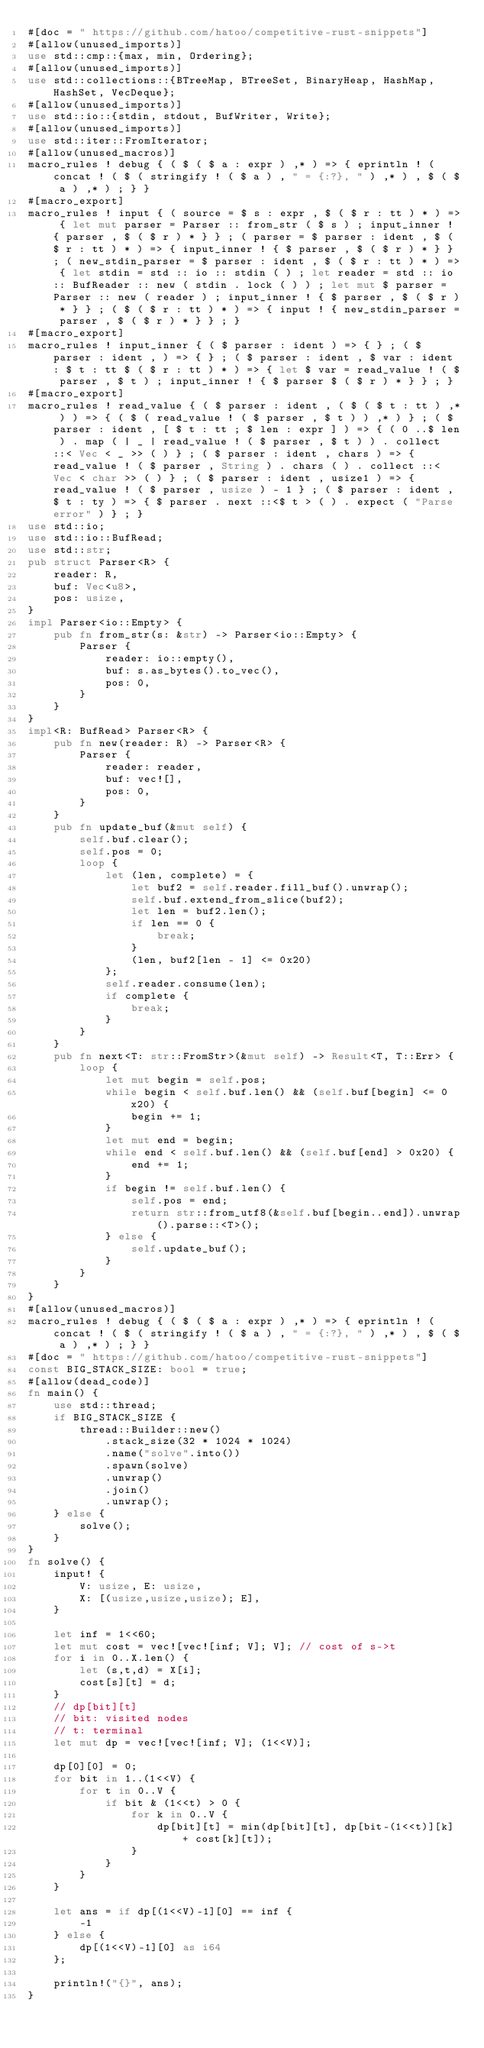<code> <loc_0><loc_0><loc_500><loc_500><_Rust_>#[doc = " https://github.com/hatoo/competitive-rust-snippets"]
#[allow(unused_imports)]
use std::cmp::{max, min, Ordering};
#[allow(unused_imports)]
use std::collections::{BTreeMap, BTreeSet, BinaryHeap, HashMap, HashSet, VecDeque};
#[allow(unused_imports)]
use std::io::{stdin, stdout, BufWriter, Write};
#[allow(unused_imports)]
use std::iter::FromIterator;
#[allow(unused_macros)]
macro_rules ! debug { ( $ ( $ a : expr ) ,* ) => { eprintln ! ( concat ! ( $ ( stringify ! ( $ a ) , " = {:?}, " ) ,* ) , $ ( $ a ) ,* ) ; } }
#[macro_export]
macro_rules ! input { ( source = $ s : expr , $ ( $ r : tt ) * ) => { let mut parser = Parser :: from_str ( $ s ) ; input_inner ! { parser , $ ( $ r ) * } } ; ( parser = $ parser : ident , $ ( $ r : tt ) * ) => { input_inner ! { $ parser , $ ( $ r ) * } } ; ( new_stdin_parser = $ parser : ident , $ ( $ r : tt ) * ) => { let stdin = std :: io :: stdin ( ) ; let reader = std :: io :: BufReader :: new ( stdin . lock ( ) ) ; let mut $ parser = Parser :: new ( reader ) ; input_inner ! { $ parser , $ ( $ r ) * } } ; ( $ ( $ r : tt ) * ) => { input ! { new_stdin_parser = parser , $ ( $ r ) * } } ; }
#[macro_export]
macro_rules ! input_inner { ( $ parser : ident ) => { } ; ( $ parser : ident , ) => { } ; ( $ parser : ident , $ var : ident : $ t : tt $ ( $ r : tt ) * ) => { let $ var = read_value ! ( $ parser , $ t ) ; input_inner ! { $ parser $ ( $ r ) * } } ; }
#[macro_export]
macro_rules ! read_value { ( $ parser : ident , ( $ ( $ t : tt ) ,* ) ) => { ( $ ( read_value ! ( $ parser , $ t ) ) ,* ) } ; ( $ parser : ident , [ $ t : tt ; $ len : expr ] ) => { ( 0 ..$ len ) . map ( | _ | read_value ! ( $ parser , $ t ) ) . collect ::< Vec < _ >> ( ) } ; ( $ parser : ident , chars ) => { read_value ! ( $ parser , String ) . chars ( ) . collect ::< Vec < char >> ( ) } ; ( $ parser : ident , usize1 ) => { read_value ! ( $ parser , usize ) - 1 } ; ( $ parser : ident , $ t : ty ) => { $ parser . next ::<$ t > ( ) . expect ( "Parse error" ) } ; }
use std::io;
use std::io::BufRead;
use std::str;
pub struct Parser<R> {
    reader: R,
    buf: Vec<u8>,
    pos: usize,
}
impl Parser<io::Empty> {
    pub fn from_str(s: &str) -> Parser<io::Empty> {
        Parser {
            reader: io::empty(),
            buf: s.as_bytes().to_vec(),
            pos: 0,
        }
    }
}
impl<R: BufRead> Parser<R> {
    pub fn new(reader: R) -> Parser<R> {
        Parser {
            reader: reader,
            buf: vec![],
            pos: 0,
        }
    }
    pub fn update_buf(&mut self) {
        self.buf.clear();
        self.pos = 0;
        loop {
            let (len, complete) = {
                let buf2 = self.reader.fill_buf().unwrap();
                self.buf.extend_from_slice(buf2);
                let len = buf2.len();
                if len == 0 {
                    break;
                }
                (len, buf2[len - 1] <= 0x20)
            };
            self.reader.consume(len);
            if complete {
                break;
            }
        }
    }
    pub fn next<T: str::FromStr>(&mut self) -> Result<T, T::Err> {
        loop {
            let mut begin = self.pos;
            while begin < self.buf.len() && (self.buf[begin] <= 0x20) {
                begin += 1;
            }
            let mut end = begin;
            while end < self.buf.len() && (self.buf[end] > 0x20) {
                end += 1;
            }
            if begin != self.buf.len() {
                self.pos = end;
                return str::from_utf8(&self.buf[begin..end]).unwrap().parse::<T>();
            } else {
                self.update_buf();
            }
        }
    }
}
#[allow(unused_macros)]
macro_rules ! debug { ( $ ( $ a : expr ) ,* ) => { eprintln ! ( concat ! ( $ ( stringify ! ( $ a ) , " = {:?}, " ) ,* ) , $ ( $ a ) ,* ) ; } }
#[doc = " https://github.com/hatoo/competitive-rust-snippets"]
const BIG_STACK_SIZE: bool = true;
#[allow(dead_code)]
fn main() {
    use std::thread;
    if BIG_STACK_SIZE {
        thread::Builder::new()
            .stack_size(32 * 1024 * 1024)
            .name("solve".into())
            .spawn(solve)
            .unwrap()
            .join()
            .unwrap();
    } else {
        solve();
    }
}
fn solve() {
    input! {
        V: usize, E: usize,
        X: [(usize,usize,usize); E],
    }

    let inf = 1<<60;
    let mut cost = vec![vec![inf; V]; V]; // cost of s->t
    for i in 0..X.len() {
        let (s,t,d) = X[i];
        cost[s][t] = d;
    }
    // dp[bit][t]
    // bit: visited nodes
    // t: terminal
    let mut dp = vec![vec![inf; V]; (1<<V)];

    dp[0][0] = 0;
    for bit in 1..(1<<V) {
        for t in 0..V {
            if bit & (1<<t) > 0 {
                for k in 0..V {
                    dp[bit][t] = min(dp[bit][t], dp[bit-(1<<t)][k] + cost[k][t]);
                }
            }
        }
    }

    let ans = if dp[(1<<V)-1][0] == inf {
        -1
    } else {
        dp[(1<<V)-1][0] as i64
    };

    println!("{}", ans);
}
</code> 